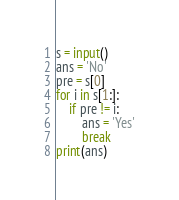Convert code to text. <code><loc_0><loc_0><loc_500><loc_500><_Python_>s = input()
ans = 'No'
pre = s[0]
for i in s[1:]:
    if pre != i:
        ans = 'Yes'
        break
print(ans)</code> 